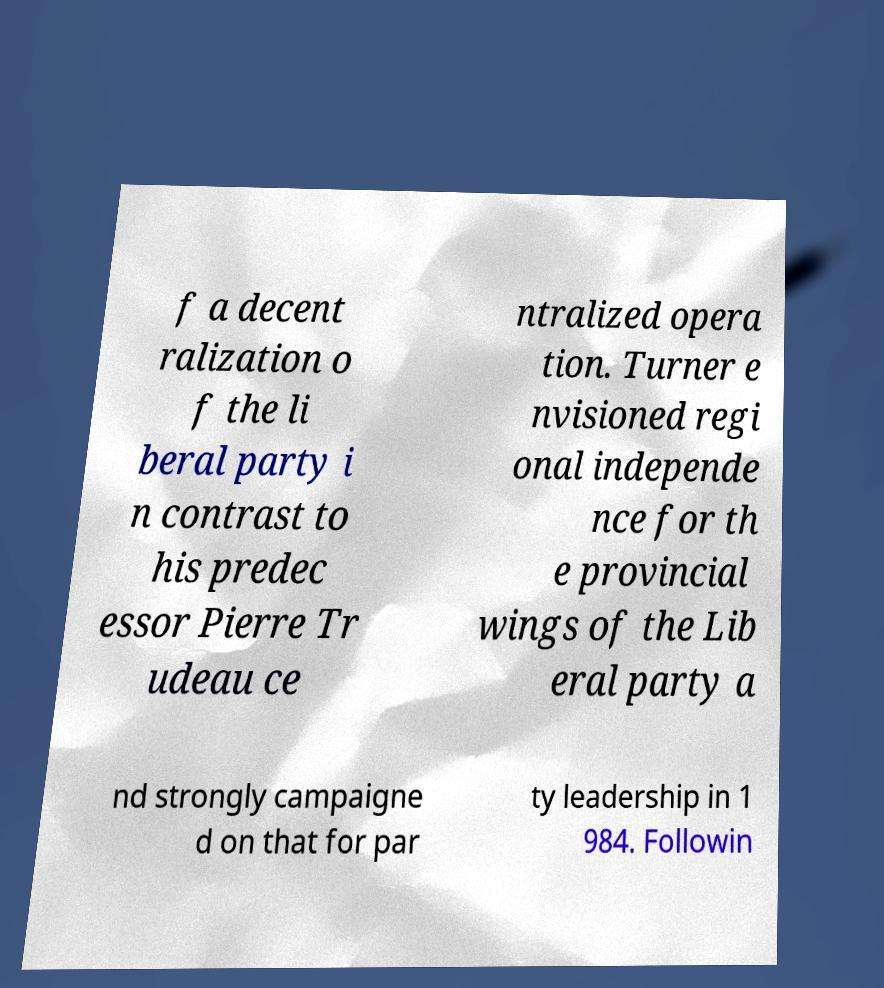Could you assist in decoding the text presented in this image and type it out clearly? f a decent ralization o f the li beral party i n contrast to his predec essor Pierre Tr udeau ce ntralized opera tion. Turner e nvisioned regi onal independe nce for th e provincial wings of the Lib eral party a nd strongly campaigne d on that for par ty leadership in 1 984. Followin 